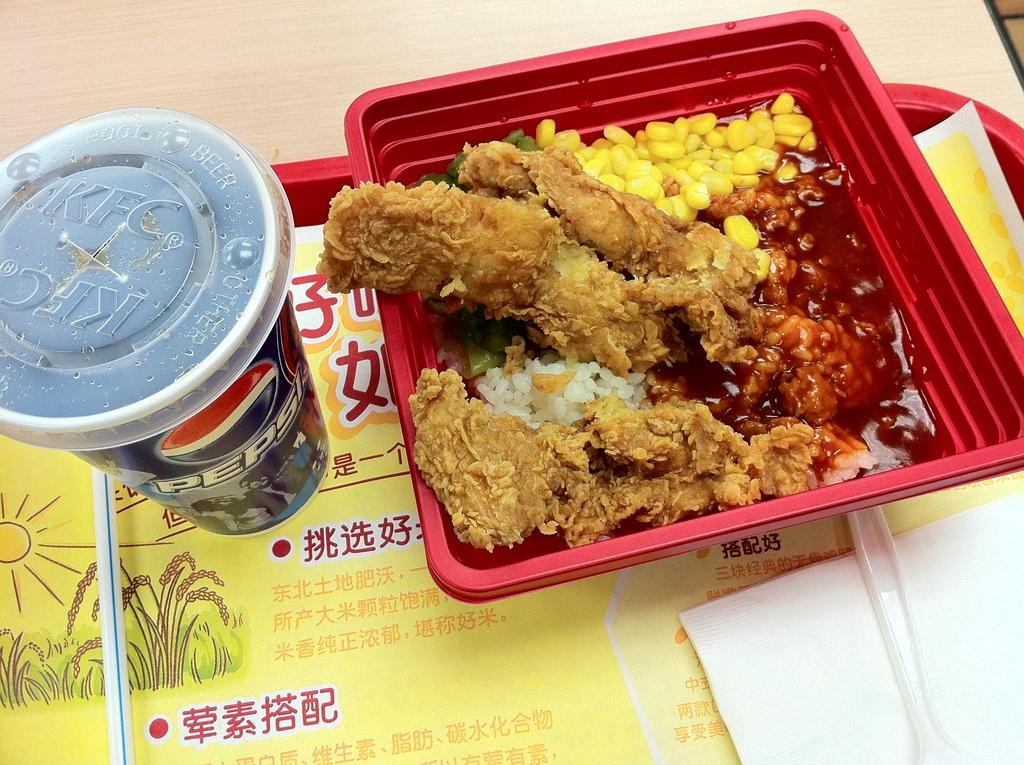What type of beverage container is in the image? There is a coke can in the image. What type of food is in the image? There is a bowl of food in the image. Where is the bowl of food located in relation to the coke can? The bowl of food is placed on the right side. How are the coke can and bowl of food arranged in the image? The coke can and bowl of food are placed in a tray. What is the surface on which the tray is placed? The tray is placed on a wooden table. What type of cloth is draped over the wren in the image? There is no wren or cloth present in the image. What is the reason for the coke can and bowl of food being placed in the tray? The image does not provide information about the reason for placing the coke can and bowl of food in the tray. 